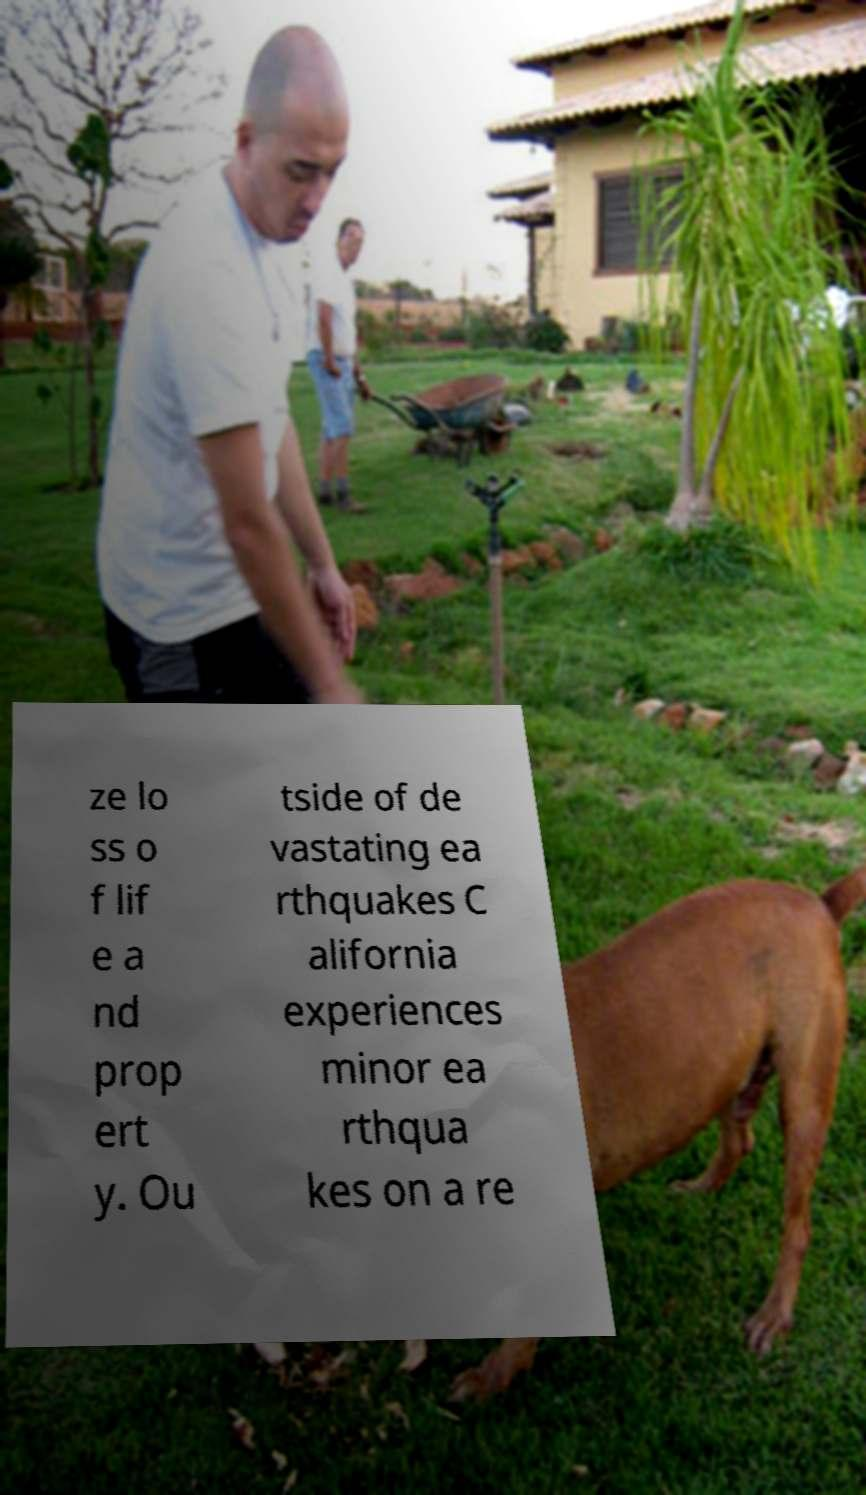Can you read and provide the text displayed in the image?This photo seems to have some interesting text. Can you extract and type it out for me? ze lo ss o f lif e a nd prop ert y. Ou tside of de vastating ea rthquakes C alifornia experiences minor ea rthqua kes on a re 